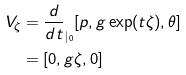<formula> <loc_0><loc_0><loc_500><loc_500>V _ { \zeta } & = \frac { d } { d t } _ { | _ { 0 } } [ p , g \exp ( t \zeta ) , \theta ] \\ & = [ 0 , g \zeta , 0 ]</formula> 